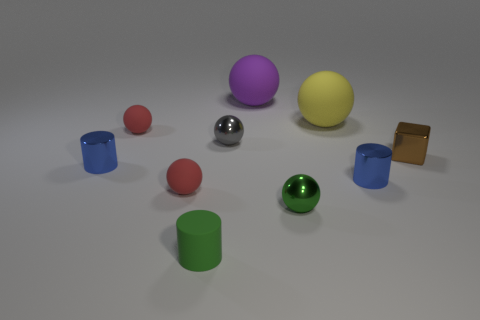Subtract all blue shiny cylinders. How many cylinders are left? 1 Subtract all blue cylinders. How many cylinders are left? 1 Subtract 1 blocks. How many blocks are left? 0 Subtract 1 green balls. How many objects are left? 9 Subtract all cylinders. How many objects are left? 7 Subtract all yellow spheres. Subtract all green blocks. How many spheres are left? 5 Subtract all purple balls. How many blue cubes are left? 0 Subtract all red spheres. Subtract all gray metallic spheres. How many objects are left? 7 Add 3 cubes. How many cubes are left? 4 Add 9 yellow cylinders. How many yellow cylinders exist? 9 